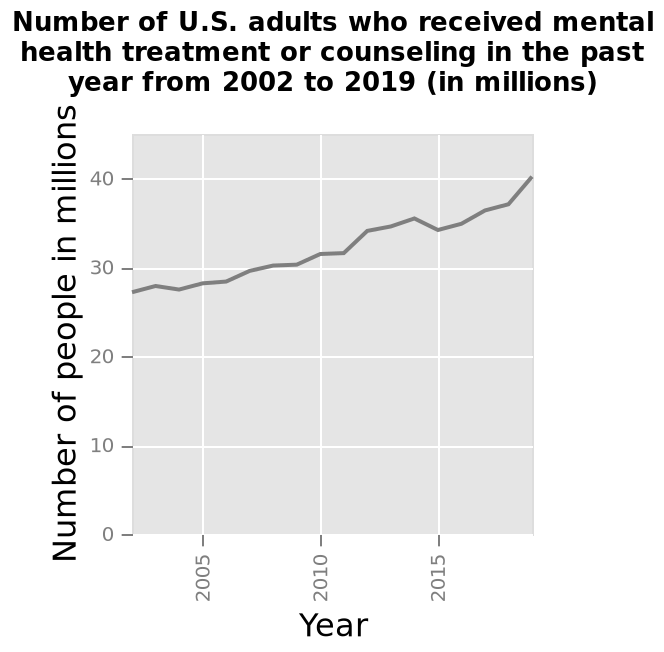<image>
What is the title of the line plot?  The title of the line plot is "Number of U.S. adults who received mental health treatment or counseling in the past year from 2002 to 2019 (in millions)." In which year did the data collection for mental health treatment or counseling end? The data collection for mental health treatment or counseling continued until 2019. What is the trend in the number of adults receiving mental support in the USA?  The number of adults receiving mental support in the USA went up drastically. 